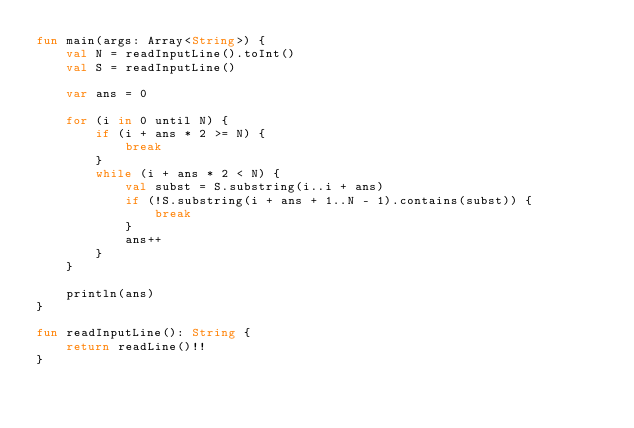Convert code to text. <code><loc_0><loc_0><loc_500><loc_500><_Kotlin_>fun main(args: Array<String>) {
    val N = readInputLine().toInt()
    val S = readInputLine()
    
    var ans = 0
    
    for (i in 0 until N) {
        if (i + ans * 2 >= N) {
            break
        }
        while (i + ans * 2 < N) {
            val subst = S.substring(i..i + ans)
            if (!S.substring(i + ans + 1..N - 1).contains(subst)) {
                break
            }
            ans++
        }
    }

    println(ans)
}

fun readInputLine(): String {
    return readLine()!!
}
</code> 